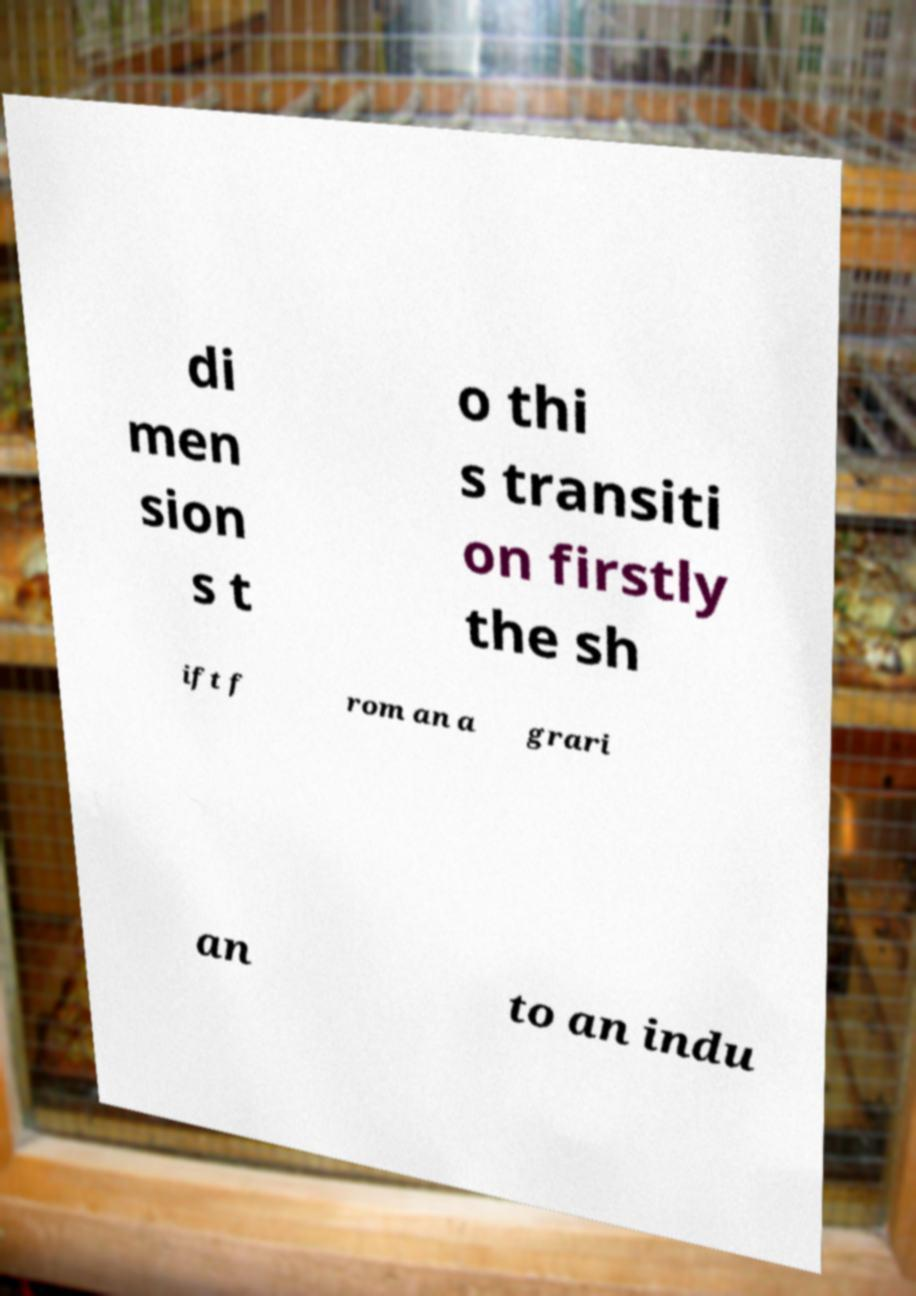There's text embedded in this image that I need extracted. Can you transcribe it verbatim? di men sion s t o thi s transiti on firstly the sh ift f rom an a grari an to an indu 